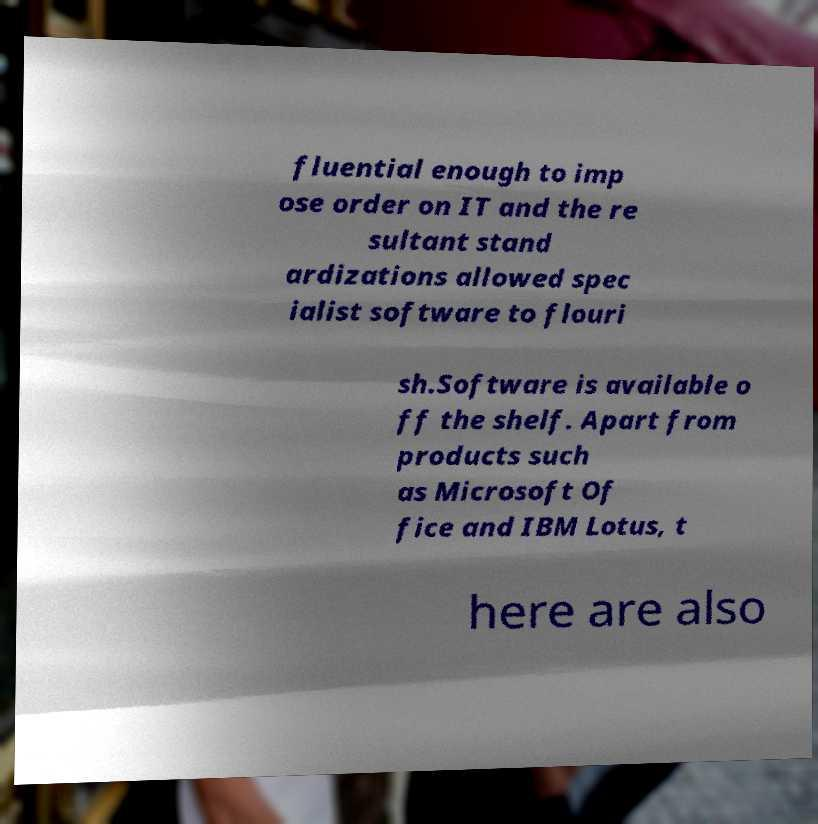For documentation purposes, I need the text within this image transcribed. Could you provide that? fluential enough to imp ose order on IT and the re sultant stand ardizations allowed spec ialist software to flouri sh.Software is available o ff the shelf. Apart from products such as Microsoft Of fice and IBM Lotus, t here are also 